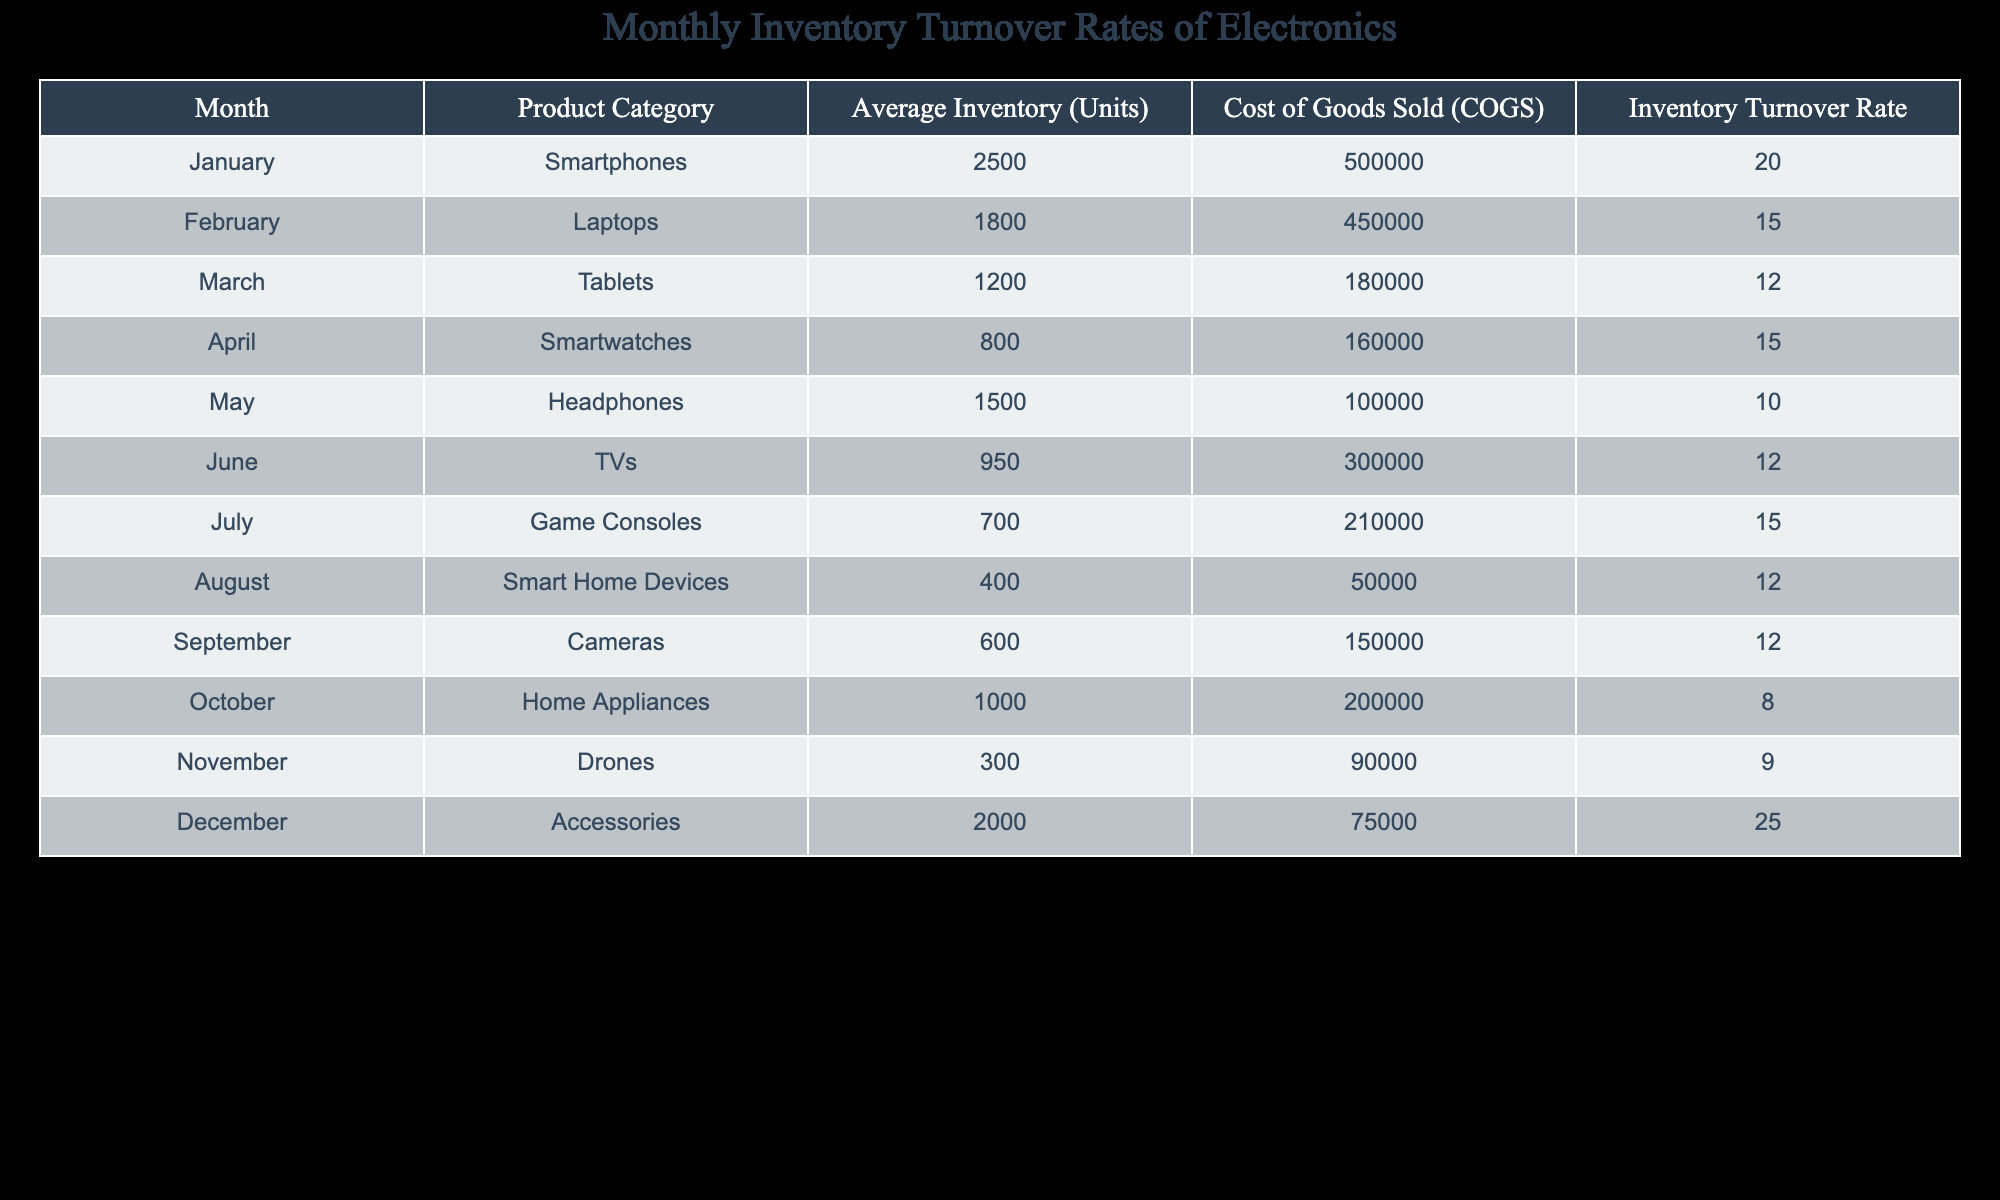What is the Inventory Turnover Rate for Headphones? According to the table, the Inventory Turnover Rate for Headphones is listed in the respective row. It clearly states a turnover rate of 10.
Answer: 10 Which product category had the highest Inventory Turnover Rate? By examining the Inventory Turnover Rate column in the table, we see that Accessories has the highest rate of 25, which is greater than all other product categories.
Answer: Accessories What is the average Inventory Turnover Rate of Laptops and Smartwatches? First, we find the Inventory Turnover Rates for Laptops (15) and Smartwatches (15). Then, we calculate the average: (15 + 15) / 2 = 15.
Answer: 15 Is the Inventory Turnover Rate for Home Appliances greater than the average of all product categories? We first identify that the Inventory Turnover Rate for Home Appliances is 8. Next, we find the average of all turnover rates: (20 + 15 + 12 + 15 + 10 + 12 + 15 + 12 + 12 + 8 + 9 + 25) / 12 = 13.5. Since 8 < 13.5, the rate for Home Appliances is not greater.
Answer: No Which two product categories had Inventory Turnover Rates that summed to 29? We look at the Inventory Turnover Rates: Accessories (25) and Smartphones (20) combined do not sum to 29. However, when we check the pair of Smartwatches (15) and Drones (9), they sum to 24. After checking all combinations, we find that the only two categories that work are Accessories (25) with nothing else reaching an exact 29. Therefore, no such categories exist.
Answer: No such categories exist 